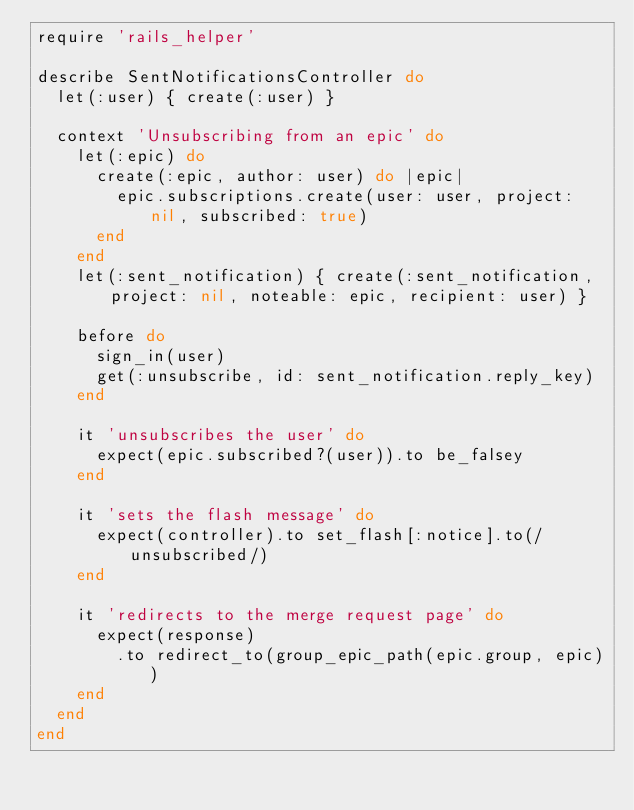<code> <loc_0><loc_0><loc_500><loc_500><_Ruby_>require 'rails_helper'

describe SentNotificationsController do
  let(:user) { create(:user) }

  context 'Unsubscribing from an epic' do
    let(:epic) do
      create(:epic, author: user) do |epic|
        epic.subscriptions.create(user: user, project: nil, subscribed: true)
      end
    end
    let(:sent_notification) { create(:sent_notification, project: nil, noteable: epic, recipient: user) }

    before do
      sign_in(user)
      get(:unsubscribe, id: sent_notification.reply_key)
    end

    it 'unsubscribes the user' do
      expect(epic.subscribed?(user)).to be_falsey
    end

    it 'sets the flash message' do
      expect(controller).to set_flash[:notice].to(/unsubscribed/)
    end

    it 'redirects to the merge request page' do
      expect(response)
        .to redirect_to(group_epic_path(epic.group, epic))
    end
  end
end
</code> 